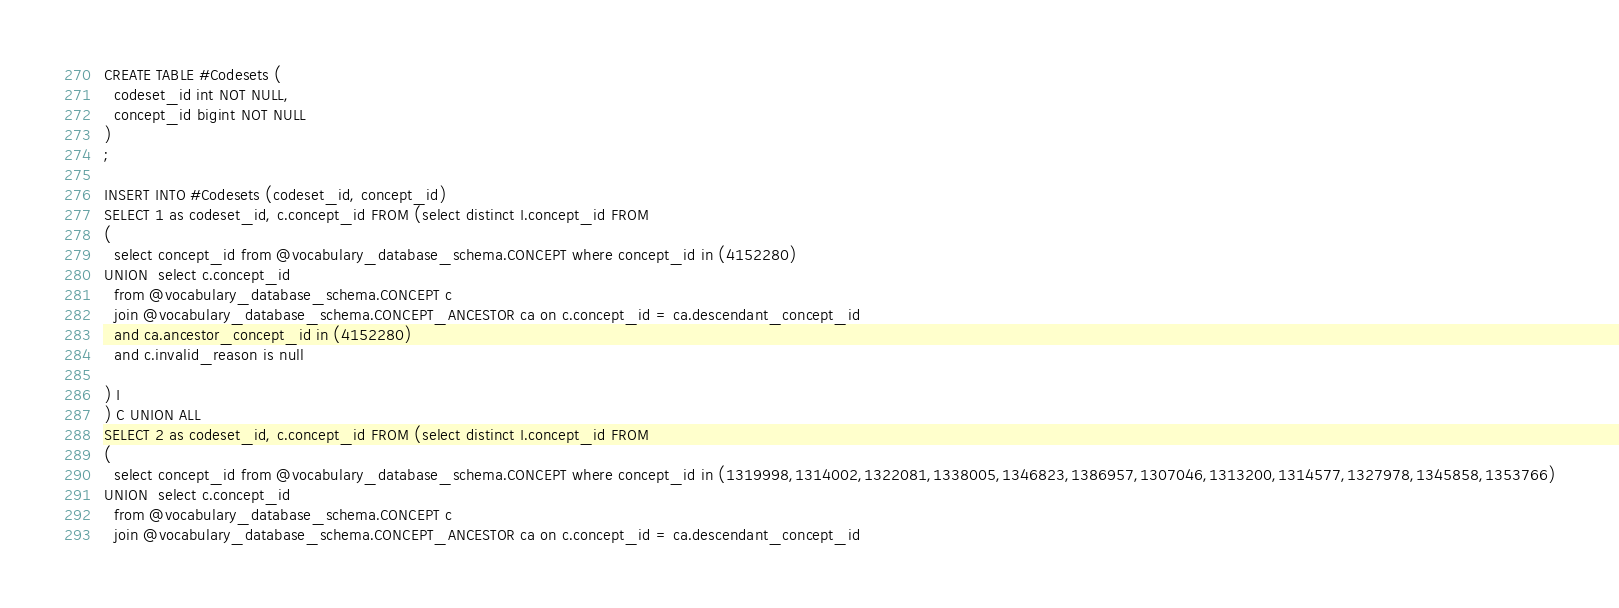Convert code to text. <code><loc_0><loc_0><loc_500><loc_500><_SQL_>CREATE TABLE #Codesets (
  codeset_id int NOT NULL,
  concept_id bigint NOT NULL
)
;

INSERT INTO #Codesets (codeset_id, concept_id)
SELECT 1 as codeset_id, c.concept_id FROM (select distinct I.concept_id FROM
( 
  select concept_id from @vocabulary_database_schema.CONCEPT where concept_id in (4152280)
UNION  select c.concept_id
  from @vocabulary_database_schema.CONCEPT c
  join @vocabulary_database_schema.CONCEPT_ANCESTOR ca on c.concept_id = ca.descendant_concept_id
  and ca.ancestor_concept_id in (4152280)
  and c.invalid_reason is null

) I
) C UNION ALL 
SELECT 2 as codeset_id, c.concept_id FROM (select distinct I.concept_id FROM
( 
  select concept_id from @vocabulary_database_schema.CONCEPT where concept_id in (1319998,1314002,1322081,1338005,1346823,1386957,1307046,1313200,1314577,1327978,1345858,1353766)
UNION  select c.concept_id
  from @vocabulary_database_schema.CONCEPT c
  join @vocabulary_database_schema.CONCEPT_ANCESTOR ca on c.concept_id = ca.descendant_concept_id</code> 